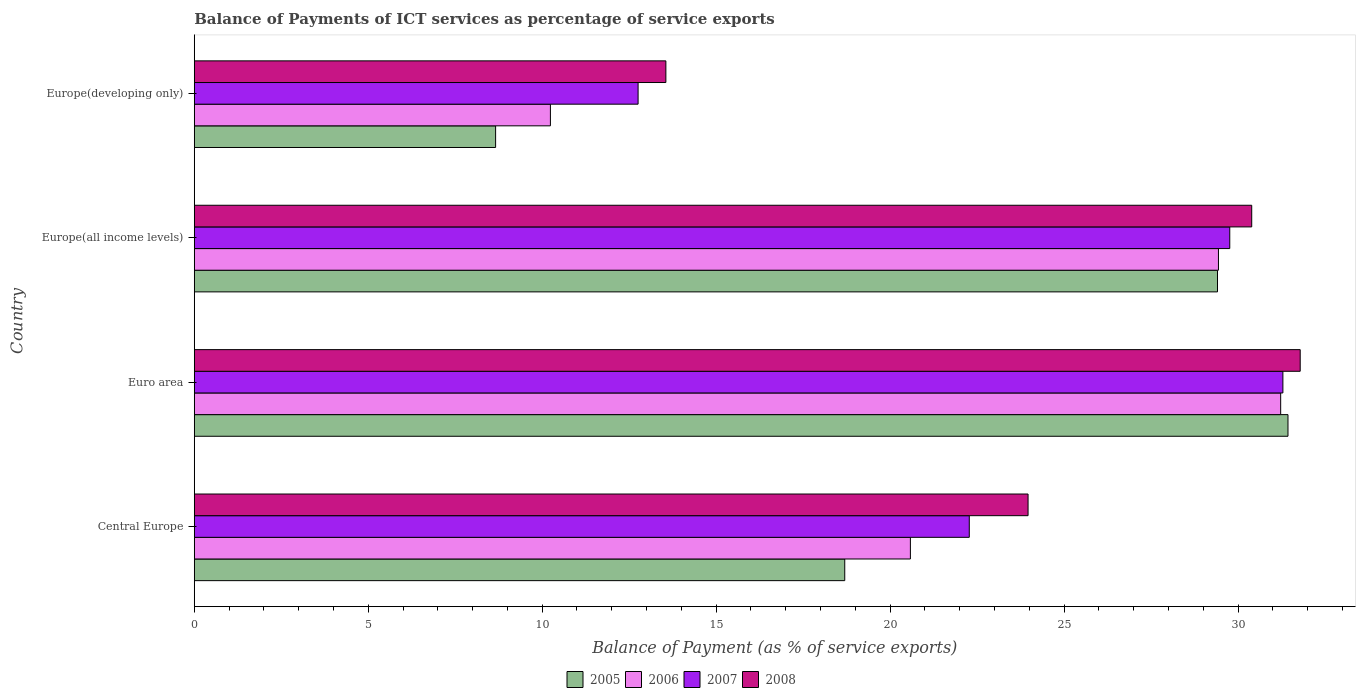How many bars are there on the 2nd tick from the top?
Keep it short and to the point. 4. How many bars are there on the 4th tick from the bottom?
Your answer should be very brief. 4. What is the label of the 3rd group of bars from the top?
Keep it short and to the point. Euro area. In how many cases, is the number of bars for a given country not equal to the number of legend labels?
Your response must be concise. 0. What is the balance of payments of ICT services in 2006 in Europe(all income levels)?
Make the answer very short. 29.44. Across all countries, what is the maximum balance of payments of ICT services in 2008?
Give a very brief answer. 31.79. Across all countries, what is the minimum balance of payments of ICT services in 2006?
Ensure brevity in your answer.  10.24. In which country was the balance of payments of ICT services in 2005 maximum?
Your response must be concise. Euro area. In which country was the balance of payments of ICT services in 2007 minimum?
Your response must be concise. Europe(developing only). What is the total balance of payments of ICT services in 2008 in the graph?
Keep it short and to the point. 99.7. What is the difference between the balance of payments of ICT services in 2006 in Euro area and that in Europe(developing only)?
Provide a succinct answer. 20.99. What is the difference between the balance of payments of ICT services in 2005 in Euro area and the balance of payments of ICT services in 2008 in Europe(developing only)?
Your answer should be very brief. 17.88. What is the average balance of payments of ICT services in 2006 per country?
Give a very brief answer. 22.87. What is the difference between the balance of payments of ICT services in 2007 and balance of payments of ICT services in 2008 in Europe(developing only)?
Provide a succinct answer. -0.8. In how many countries, is the balance of payments of ICT services in 2008 greater than 1 %?
Your answer should be compact. 4. What is the ratio of the balance of payments of ICT services in 2007 in Central Europe to that in Europe(developing only)?
Your answer should be very brief. 1.75. Is the balance of payments of ICT services in 2006 in Central Europe less than that in Euro area?
Give a very brief answer. Yes. What is the difference between the highest and the second highest balance of payments of ICT services in 2008?
Make the answer very short. 1.39. What is the difference between the highest and the lowest balance of payments of ICT services in 2008?
Your answer should be very brief. 18.23. Is the sum of the balance of payments of ICT services in 2006 in Central Europe and Europe(developing only) greater than the maximum balance of payments of ICT services in 2008 across all countries?
Offer a terse response. No. Is it the case that in every country, the sum of the balance of payments of ICT services in 2007 and balance of payments of ICT services in 2006 is greater than the sum of balance of payments of ICT services in 2008 and balance of payments of ICT services in 2005?
Offer a very short reply. No. What does the 1st bar from the top in Central Europe represents?
Your response must be concise. 2008. What does the 4th bar from the bottom in Europe(all income levels) represents?
Give a very brief answer. 2008. Are all the bars in the graph horizontal?
Your response must be concise. Yes. How many countries are there in the graph?
Provide a succinct answer. 4. What is the difference between two consecutive major ticks on the X-axis?
Your answer should be compact. 5. Are the values on the major ticks of X-axis written in scientific E-notation?
Your answer should be very brief. No. How many legend labels are there?
Offer a very short reply. 4. How are the legend labels stacked?
Ensure brevity in your answer.  Horizontal. What is the title of the graph?
Provide a short and direct response. Balance of Payments of ICT services as percentage of service exports. Does "1993" appear as one of the legend labels in the graph?
Your answer should be compact. No. What is the label or title of the X-axis?
Your answer should be very brief. Balance of Payment (as % of service exports). What is the label or title of the Y-axis?
Your answer should be compact. Country. What is the Balance of Payment (as % of service exports) of 2005 in Central Europe?
Provide a succinct answer. 18.7. What is the Balance of Payment (as % of service exports) of 2006 in Central Europe?
Your answer should be compact. 20.58. What is the Balance of Payment (as % of service exports) of 2007 in Central Europe?
Provide a succinct answer. 22.28. What is the Balance of Payment (as % of service exports) of 2008 in Central Europe?
Offer a very short reply. 23.97. What is the Balance of Payment (as % of service exports) in 2005 in Euro area?
Provide a succinct answer. 31.44. What is the Balance of Payment (as % of service exports) in 2006 in Euro area?
Keep it short and to the point. 31.23. What is the Balance of Payment (as % of service exports) in 2007 in Euro area?
Your answer should be very brief. 31.29. What is the Balance of Payment (as % of service exports) in 2008 in Euro area?
Make the answer very short. 31.79. What is the Balance of Payment (as % of service exports) in 2005 in Europe(all income levels)?
Provide a succinct answer. 29.41. What is the Balance of Payment (as % of service exports) in 2006 in Europe(all income levels)?
Your answer should be compact. 29.44. What is the Balance of Payment (as % of service exports) in 2007 in Europe(all income levels)?
Offer a very short reply. 29.76. What is the Balance of Payment (as % of service exports) in 2008 in Europe(all income levels)?
Offer a terse response. 30.39. What is the Balance of Payment (as % of service exports) in 2005 in Europe(developing only)?
Keep it short and to the point. 8.66. What is the Balance of Payment (as % of service exports) of 2006 in Europe(developing only)?
Offer a very short reply. 10.24. What is the Balance of Payment (as % of service exports) in 2007 in Europe(developing only)?
Ensure brevity in your answer.  12.76. What is the Balance of Payment (as % of service exports) in 2008 in Europe(developing only)?
Provide a short and direct response. 13.56. Across all countries, what is the maximum Balance of Payment (as % of service exports) of 2005?
Your response must be concise. 31.44. Across all countries, what is the maximum Balance of Payment (as % of service exports) in 2006?
Provide a succinct answer. 31.23. Across all countries, what is the maximum Balance of Payment (as % of service exports) of 2007?
Your answer should be compact. 31.29. Across all countries, what is the maximum Balance of Payment (as % of service exports) in 2008?
Provide a succinct answer. 31.79. Across all countries, what is the minimum Balance of Payment (as % of service exports) in 2005?
Offer a very short reply. 8.66. Across all countries, what is the minimum Balance of Payment (as % of service exports) of 2006?
Make the answer very short. 10.24. Across all countries, what is the minimum Balance of Payment (as % of service exports) in 2007?
Your answer should be compact. 12.76. Across all countries, what is the minimum Balance of Payment (as % of service exports) in 2008?
Provide a succinct answer. 13.56. What is the total Balance of Payment (as % of service exports) in 2005 in the graph?
Ensure brevity in your answer.  88.2. What is the total Balance of Payment (as % of service exports) in 2006 in the graph?
Your response must be concise. 91.48. What is the total Balance of Payment (as % of service exports) in 2007 in the graph?
Offer a terse response. 96.08. What is the total Balance of Payment (as % of service exports) of 2008 in the graph?
Provide a short and direct response. 99.7. What is the difference between the Balance of Payment (as % of service exports) of 2005 in Central Europe and that in Euro area?
Offer a very short reply. -12.74. What is the difference between the Balance of Payment (as % of service exports) in 2006 in Central Europe and that in Euro area?
Keep it short and to the point. -10.64. What is the difference between the Balance of Payment (as % of service exports) of 2007 in Central Europe and that in Euro area?
Offer a very short reply. -9.01. What is the difference between the Balance of Payment (as % of service exports) in 2008 in Central Europe and that in Euro area?
Make the answer very short. -7.82. What is the difference between the Balance of Payment (as % of service exports) of 2005 in Central Europe and that in Europe(all income levels)?
Keep it short and to the point. -10.71. What is the difference between the Balance of Payment (as % of service exports) of 2006 in Central Europe and that in Europe(all income levels)?
Offer a terse response. -8.85. What is the difference between the Balance of Payment (as % of service exports) of 2007 in Central Europe and that in Europe(all income levels)?
Give a very brief answer. -7.49. What is the difference between the Balance of Payment (as % of service exports) of 2008 in Central Europe and that in Europe(all income levels)?
Make the answer very short. -6.43. What is the difference between the Balance of Payment (as % of service exports) of 2005 in Central Europe and that in Europe(developing only)?
Provide a short and direct response. 10.04. What is the difference between the Balance of Payment (as % of service exports) of 2006 in Central Europe and that in Europe(developing only)?
Give a very brief answer. 10.35. What is the difference between the Balance of Payment (as % of service exports) of 2007 in Central Europe and that in Europe(developing only)?
Ensure brevity in your answer.  9.52. What is the difference between the Balance of Payment (as % of service exports) of 2008 in Central Europe and that in Europe(developing only)?
Make the answer very short. 10.41. What is the difference between the Balance of Payment (as % of service exports) of 2005 in Euro area and that in Europe(all income levels)?
Your answer should be very brief. 2.03. What is the difference between the Balance of Payment (as % of service exports) of 2006 in Euro area and that in Europe(all income levels)?
Provide a succinct answer. 1.79. What is the difference between the Balance of Payment (as % of service exports) of 2007 in Euro area and that in Europe(all income levels)?
Your answer should be very brief. 1.53. What is the difference between the Balance of Payment (as % of service exports) in 2008 in Euro area and that in Europe(all income levels)?
Offer a terse response. 1.39. What is the difference between the Balance of Payment (as % of service exports) of 2005 in Euro area and that in Europe(developing only)?
Ensure brevity in your answer.  22.77. What is the difference between the Balance of Payment (as % of service exports) of 2006 in Euro area and that in Europe(developing only)?
Your answer should be compact. 20.99. What is the difference between the Balance of Payment (as % of service exports) of 2007 in Euro area and that in Europe(developing only)?
Provide a short and direct response. 18.53. What is the difference between the Balance of Payment (as % of service exports) in 2008 in Euro area and that in Europe(developing only)?
Provide a short and direct response. 18.23. What is the difference between the Balance of Payment (as % of service exports) of 2005 in Europe(all income levels) and that in Europe(developing only)?
Offer a terse response. 20.75. What is the difference between the Balance of Payment (as % of service exports) of 2006 in Europe(all income levels) and that in Europe(developing only)?
Make the answer very short. 19.2. What is the difference between the Balance of Payment (as % of service exports) of 2007 in Europe(all income levels) and that in Europe(developing only)?
Offer a very short reply. 17.01. What is the difference between the Balance of Payment (as % of service exports) in 2008 in Europe(all income levels) and that in Europe(developing only)?
Give a very brief answer. 16.84. What is the difference between the Balance of Payment (as % of service exports) of 2005 in Central Europe and the Balance of Payment (as % of service exports) of 2006 in Euro area?
Keep it short and to the point. -12.53. What is the difference between the Balance of Payment (as % of service exports) in 2005 in Central Europe and the Balance of Payment (as % of service exports) in 2007 in Euro area?
Offer a terse response. -12.59. What is the difference between the Balance of Payment (as % of service exports) of 2005 in Central Europe and the Balance of Payment (as % of service exports) of 2008 in Euro area?
Your response must be concise. -13.09. What is the difference between the Balance of Payment (as % of service exports) of 2006 in Central Europe and the Balance of Payment (as % of service exports) of 2007 in Euro area?
Offer a terse response. -10.71. What is the difference between the Balance of Payment (as % of service exports) in 2006 in Central Europe and the Balance of Payment (as % of service exports) in 2008 in Euro area?
Your answer should be very brief. -11.2. What is the difference between the Balance of Payment (as % of service exports) of 2007 in Central Europe and the Balance of Payment (as % of service exports) of 2008 in Euro area?
Ensure brevity in your answer.  -9.51. What is the difference between the Balance of Payment (as % of service exports) of 2005 in Central Europe and the Balance of Payment (as % of service exports) of 2006 in Europe(all income levels)?
Provide a succinct answer. -10.74. What is the difference between the Balance of Payment (as % of service exports) of 2005 in Central Europe and the Balance of Payment (as % of service exports) of 2007 in Europe(all income levels)?
Give a very brief answer. -11.07. What is the difference between the Balance of Payment (as % of service exports) in 2005 in Central Europe and the Balance of Payment (as % of service exports) in 2008 in Europe(all income levels)?
Offer a very short reply. -11.7. What is the difference between the Balance of Payment (as % of service exports) in 2006 in Central Europe and the Balance of Payment (as % of service exports) in 2007 in Europe(all income levels)?
Provide a succinct answer. -9.18. What is the difference between the Balance of Payment (as % of service exports) of 2006 in Central Europe and the Balance of Payment (as % of service exports) of 2008 in Europe(all income levels)?
Provide a short and direct response. -9.81. What is the difference between the Balance of Payment (as % of service exports) of 2007 in Central Europe and the Balance of Payment (as % of service exports) of 2008 in Europe(all income levels)?
Your answer should be compact. -8.12. What is the difference between the Balance of Payment (as % of service exports) in 2005 in Central Europe and the Balance of Payment (as % of service exports) in 2006 in Europe(developing only)?
Provide a succinct answer. 8.46. What is the difference between the Balance of Payment (as % of service exports) in 2005 in Central Europe and the Balance of Payment (as % of service exports) in 2007 in Europe(developing only)?
Offer a very short reply. 5.94. What is the difference between the Balance of Payment (as % of service exports) of 2005 in Central Europe and the Balance of Payment (as % of service exports) of 2008 in Europe(developing only)?
Your answer should be very brief. 5.14. What is the difference between the Balance of Payment (as % of service exports) of 2006 in Central Europe and the Balance of Payment (as % of service exports) of 2007 in Europe(developing only)?
Offer a terse response. 7.83. What is the difference between the Balance of Payment (as % of service exports) in 2006 in Central Europe and the Balance of Payment (as % of service exports) in 2008 in Europe(developing only)?
Provide a succinct answer. 7.03. What is the difference between the Balance of Payment (as % of service exports) of 2007 in Central Europe and the Balance of Payment (as % of service exports) of 2008 in Europe(developing only)?
Provide a succinct answer. 8.72. What is the difference between the Balance of Payment (as % of service exports) of 2005 in Euro area and the Balance of Payment (as % of service exports) of 2006 in Europe(all income levels)?
Your answer should be very brief. 2. What is the difference between the Balance of Payment (as % of service exports) of 2005 in Euro area and the Balance of Payment (as % of service exports) of 2007 in Europe(all income levels)?
Provide a short and direct response. 1.67. What is the difference between the Balance of Payment (as % of service exports) of 2005 in Euro area and the Balance of Payment (as % of service exports) of 2008 in Europe(all income levels)?
Offer a very short reply. 1.04. What is the difference between the Balance of Payment (as % of service exports) in 2006 in Euro area and the Balance of Payment (as % of service exports) in 2007 in Europe(all income levels)?
Offer a terse response. 1.46. What is the difference between the Balance of Payment (as % of service exports) in 2006 in Euro area and the Balance of Payment (as % of service exports) in 2008 in Europe(all income levels)?
Your answer should be very brief. 0.83. What is the difference between the Balance of Payment (as % of service exports) of 2007 in Euro area and the Balance of Payment (as % of service exports) of 2008 in Europe(all income levels)?
Offer a very short reply. 0.9. What is the difference between the Balance of Payment (as % of service exports) in 2005 in Euro area and the Balance of Payment (as % of service exports) in 2006 in Europe(developing only)?
Offer a very short reply. 21.2. What is the difference between the Balance of Payment (as % of service exports) of 2005 in Euro area and the Balance of Payment (as % of service exports) of 2007 in Europe(developing only)?
Your answer should be very brief. 18.68. What is the difference between the Balance of Payment (as % of service exports) in 2005 in Euro area and the Balance of Payment (as % of service exports) in 2008 in Europe(developing only)?
Make the answer very short. 17.88. What is the difference between the Balance of Payment (as % of service exports) of 2006 in Euro area and the Balance of Payment (as % of service exports) of 2007 in Europe(developing only)?
Keep it short and to the point. 18.47. What is the difference between the Balance of Payment (as % of service exports) in 2006 in Euro area and the Balance of Payment (as % of service exports) in 2008 in Europe(developing only)?
Give a very brief answer. 17.67. What is the difference between the Balance of Payment (as % of service exports) in 2007 in Euro area and the Balance of Payment (as % of service exports) in 2008 in Europe(developing only)?
Provide a succinct answer. 17.73. What is the difference between the Balance of Payment (as % of service exports) of 2005 in Europe(all income levels) and the Balance of Payment (as % of service exports) of 2006 in Europe(developing only)?
Provide a short and direct response. 19.17. What is the difference between the Balance of Payment (as % of service exports) in 2005 in Europe(all income levels) and the Balance of Payment (as % of service exports) in 2007 in Europe(developing only)?
Your answer should be very brief. 16.65. What is the difference between the Balance of Payment (as % of service exports) of 2005 in Europe(all income levels) and the Balance of Payment (as % of service exports) of 2008 in Europe(developing only)?
Provide a succinct answer. 15.86. What is the difference between the Balance of Payment (as % of service exports) of 2006 in Europe(all income levels) and the Balance of Payment (as % of service exports) of 2007 in Europe(developing only)?
Provide a short and direct response. 16.68. What is the difference between the Balance of Payment (as % of service exports) in 2006 in Europe(all income levels) and the Balance of Payment (as % of service exports) in 2008 in Europe(developing only)?
Provide a short and direct response. 15.88. What is the difference between the Balance of Payment (as % of service exports) in 2007 in Europe(all income levels) and the Balance of Payment (as % of service exports) in 2008 in Europe(developing only)?
Ensure brevity in your answer.  16.21. What is the average Balance of Payment (as % of service exports) of 2005 per country?
Offer a very short reply. 22.05. What is the average Balance of Payment (as % of service exports) in 2006 per country?
Give a very brief answer. 22.87. What is the average Balance of Payment (as % of service exports) of 2007 per country?
Keep it short and to the point. 24.02. What is the average Balance of Payment (as % of service exports) in 2008 per country?
Provide a succinct answer. 24.93. What is the difference between the Balance of Payment (as % of service exports) in 2005 and Balance of Payment (as % of service exports) in 2006 in Central Europe?
Your answer should be compact. -1.89. What is the difference between the Balance of Payment (as % of service exports) of 2005 and Balance of Payment (as % of service exports) of 2007 in Central Europe?
Provide a short and direct response. -3.58. What is the difference between the Balance of Payment (as % of service exports) of 2005 and Balance of Payment (as % of service exports) of 2008 in Central Europe?
Ensure brevity in your answer.  -5.27. What is the difference between the Balance of Payment (as % of service exports) in 2006 and Balance of Payment (as % of service exports) in 2007 in Central Europe?
Ensure brevity in your answer.  -1.69. What is the difference between the Balance of Payment (as % of service exports) of 2006 and Balance of Payment (as % of service exports) of 2008 in Central Europe?
Offer a terse response. -3.38. What is the difference between the Balance of Payment (as % of service exports) of 2007 and Balance of Payment (as % of service exports) of 2008 in Central Europe?
Offer a very short reply. -1.69. What is the difference between the Balance of Payment (as % of service exports) of 2005 and Balance of Payment (as % of service exports) of 2006 in Euro area?
Provide a succinct answer. 0.21. What is the difference between the Balance of Payment (as % of service exports) of 2005 and Balance of Payment (as % of service exports) of 2007 in Euro area?
Your answer should be compact. 0.15. What is the difference between the Balance of Payment (as % of service exports) in 2005 and Balance of Payment (as % of service exports) in 2008 in Euro area?
Ensure brevity in your answer.  -0.35. What is the difference between the Balance of Payment (as % of service exports) in 2006 and Balance of Payment (as % of service exports) in 2007 in Euro area?
Provide a short and direct response. -0.06. What is the difference between the Balance of Payment (as % of service exports) in 2006 and Balance of Payment (as % of service exports) in 2008 in Euro area?
Your response must be concise. -0.56. What is the difference between the Balance of Payment (as % of service exports) of 2007 and Balance of Payment (as % of service exports) of 2008 in Euro area?
Offer a terse response. -0.5. What is the difference between the Balance of Payment (as % of service exports) of 2005 and Balance of Payment (as % of service exports) of 2006 in Europe(all income levels)?
Provide a succinct answer. -0.03. What is the difference between the Balance of Payment (as % of service exports) of 2005 and Balance of Payment (as % of service exports) of 2007 in Europe(all income levels)?
Keep it short and to the point. -0.35. What is the difference between the Balance of Payment (as % of service exports) of 2005 and Balance of Payment (as % of service exports) of 2008 in Europe(all income levels)?
Give a very brief answer. -0.98. What is the difference between the Balance of Payment (as % of service exports) in 2006 and Balance of Payment (as % of service exports) in 2007 in Europe(all income levels)?
Provide a short and direct response. -0.33. What is the difference between the Balance of Payment (as % of service exports) of 2006 and Balance of Payment (as % of service exports) of 2008 in Europe(all income levels)?
Your answer should be compact. -0.96. What is the difference between the Balance of Payment (as % of service exports) of 2007 and Balance of Payment (as % of service exports) of 2008 in Europe(all income levels)?
Ensure brevity in your answer.  -0.63. What is the difference between the Balance of Payment (as % of service exports) of 2005 and Balance of Payment (as % of service exports) of 2006 in Europe(developing only)?
Ensure brevity in your answer.  -1.57. What is the difference between the Balance of Payment (as % of service exports) in 2005 and Balance of Payment (as % of service exports) in 2007 in Europe(developing only)?
Give a very brief answer. -4.1. What is the difference between the Balance of Payment (as % of service exports) of 2005 and Balance of Payment (as % of service exports) of 2008 in Europe(developing only)?
Your answer should be very brief. -4.89. What is the difference between the Balance of Payment (as % of service exports) in 2006 and Balance of Payment (as % of service exports) in 2007 in Europe(developing only)?
Offer a very short reply. -2.52. What is the difference between the Balance of Payment (as % of service exports) in 2006 and Balance of Payment (as % of service exports) in 2008 in Europe(developing only)?
Give a very brief answer. -3.32. What is the difference between the Balance of Payment (as % of service exports) in 2007 and Balance of Payment (as % of service exports) in 2008 in Europe(developing only)?
Provide a succinct answer. -0.8. What is the ratio of the Balance of Payment (as % of service exports) of 2005 in Central Europe to that in Euro area?
Offer a very short reply. 0.59. What is the ratio of the Balance of Payment (as % of service exports) of 2006 in Central Europe to that in Euro area?
Ensure brevity in your answer.  0.66. What is the ratio of the Balance of Payment (as % of service exports) of 2007 in Central Europe to that in Euro area?
Provide a succinct answer. 0.71. What is the ratio of the Balance of Payment (as % of service exports) in 2008 in Central Europe to that in Euro area?
Your answer should be very brief. 0.75. What is the ratio of the Balance of Payment (as % of service exports) of 2005 in Central Europe to that in Europe(all income levels)?
Offer a terse response. 0.64. What is the ratio of the Balance of Payment (as % of service exports) of 2006 in Central Europe to that in Europe(all income levels)?
Your response must be concise. 0.7. What is the ratio of the Balance of Payment (as % of service exports) in 2007 in Central Europe to that in Europe(all income levels)?
Your answer should be very brief. 0.75. What is the ratio of the Balance of Payment (as % of service exports) of 2008 in Central Europe to that in Europe(all income levels)?
Provide a succinct answer. 0.79. What is the ratio of the Balance of Payment (as % of service exports) in 2005 in Central Europe to that in Europe(developing only)?
Offer a terse response. 2.16. What is the ratio of the Balance of Payment (as % of service exports) in 2006 in Central Europe to that in Europe(developing only)?
Provide a succinct answer. 2.01. What is the ratio of the Balance of Payment (as % of service exports) in 2007 in Central Europe to that in Europe(developing only)?
Offer a very short reply. 1.75. What is the ratio of the Balance of Payment (as % of service exports) of 2008 in Central Europe to that in Europe(developing only)?
Offer a very short reply. 1.77. What is the ratio of the Balance of Payment (as % of service exports) in 2005 in Euro area to that in Europe(all income levels)?
Make the answer very short. 1.07. What is the ratio of the Balance of Payment (as % of service exports) in 2006 in Euro area to that in Europe(all income levels)?
Give a very brief answer. 1.06. What is the ratio of the Balance of Payment (as % of service exports) of 2007 in Euro area to that in Europe(all income levels)?
Offer a very short reply. 1.05. What is the ratio of the Balance of Payment (as % of service exports) of 2008 in Euro area to that in Europe(all income levels)?
Provide a succinct answer. 1.05. What is the ratio of the Balance of Payment (as % of service exports) of 2005 in Euro area to that in Europe(developing only)?
Provide a short and direct response. 3.63. What is the ratio of the Balance of Payment (as % of service exports) of 2006 in Euro area to that in Europe(developing only)?
Your answer should be compact. 3.05. What is the ratio of the Balance of Payment (as % of service exports) in 2007 in Euro area to that in Europe(developing only)?
Your answer should be compact. 2.45. What is the ratio of the Balance of Payment (as % of service exports) of 2008 in Euro area to that in Europe(developing only)?
Offer a terse response. 2.35. What is the ratio of the Balance of Payment (as % of service exports) of 2005 in Europe(all income levels) to that in Europe(developing only)?
Make the answer very short. 3.4. What is the ratio of the Balance of Payment (as % of service exports) of 2006 in Europe(all income levels) to that in Europe(developing only)?
Offer a very short reply. 2.88. What is the ratio of the Balance of Payment (as % of service exports) of 2007 in Europe(all income levels) to that in Europe(developing only)?
Keep it short and to the point. 2.33. What is the ratio of the Balance of Payment (as % of service exports) of 2008 in Europe(all income levels) to that in Europe(developing only)?
Your response must be concise. 2.24. What is the difference between the highest and the second highest Balance of Payment (as % of service exports) of 2005?
Offer a terse response. 2.03. What is the difference between the highest and the second highest Balance of Payment (as % of service exports) in 2006?
Keep it short and to the point. 1.79. What is the difference between the highest and the second highest Balance of Payment (as % of service exports) of 2007?
Give a very brief answer. 1.53. What is the difference between the highest and the second highest Balance of Payment (as % of service exports) in 2008?
Ensure brevity in your answer.  1.39. What is the difference between the highest and the lowest Balance of Payment (as % of service exports) of 2005?
Offer a terse response. 22.77. What is the difference between the highest and the lowest Balance of Payment (as % of service exports) in 2006?
Keep it short and to the point. 20.99. What is the difference between the highest and the lowest Balance of Payment (as % of service exports) in 2007?
Your answer should be very brief. 18.53. What is the difference between the highest and the lowest Balance of Payment (as % of service exports) of 2008?
Make the answer very short. 18.23. 